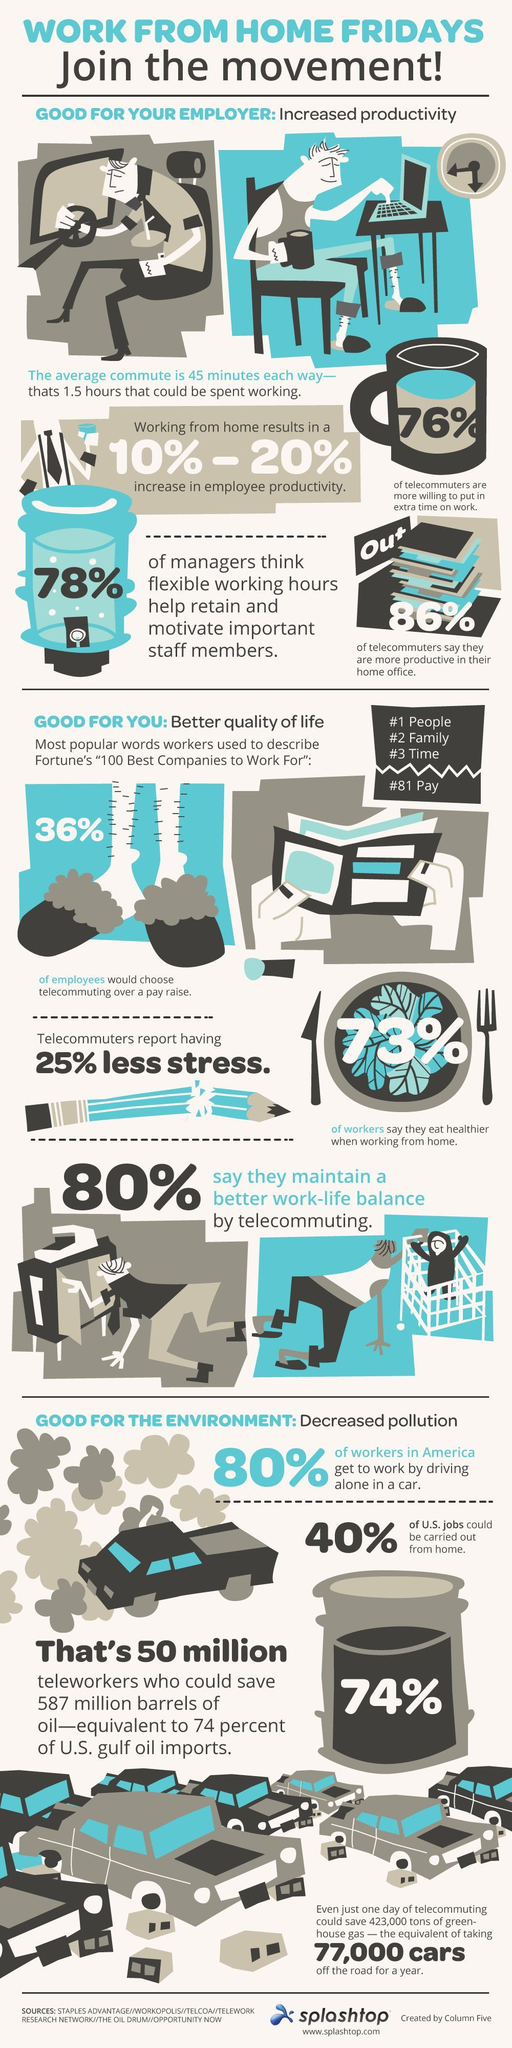What percent of people will choose telecommuting over pay?
Answer the question with a short phrase. 36% What percent of telecommuters are willing to do extra time of work? 76% 